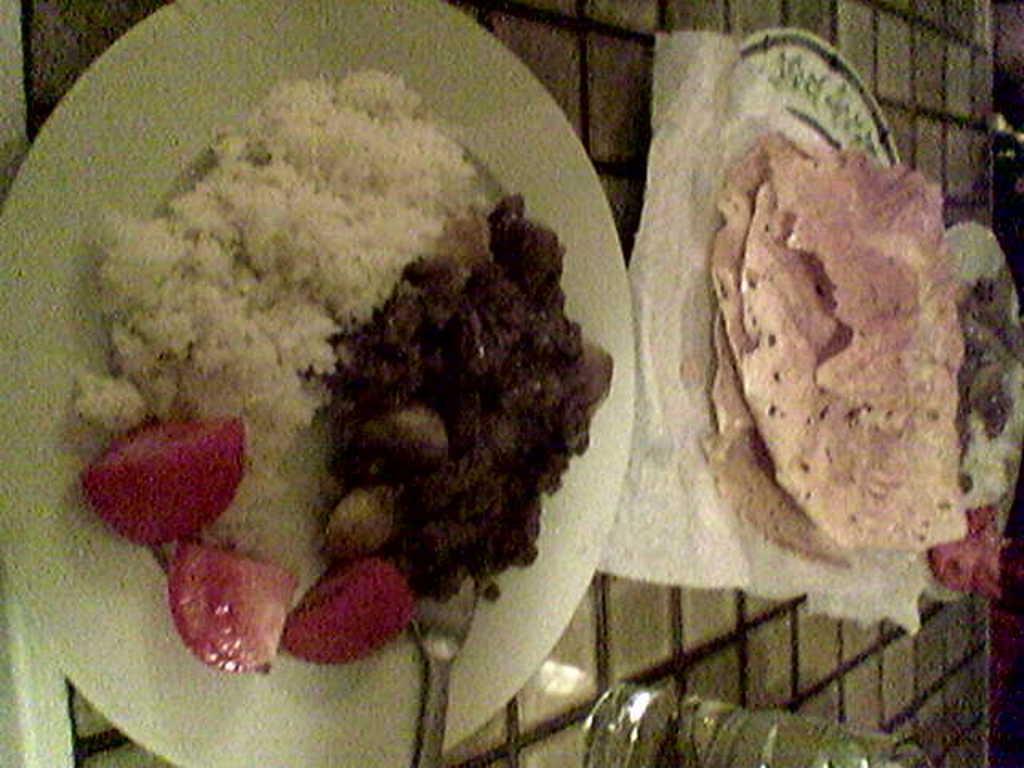Could you give a brief overview of what you see in this image? This looks like a table. I can see three plates, which contains food items and a glass of water are placed on the table. This looks like a spoon, which is kept on the plate. 